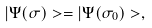Convert formula to latex. <formula><loc_0><loc_0><loc_500><loc_500>| \Psi ( \sigma ) > = | \Psi ( \sigma _ { 0 } ) > ,</formula> 